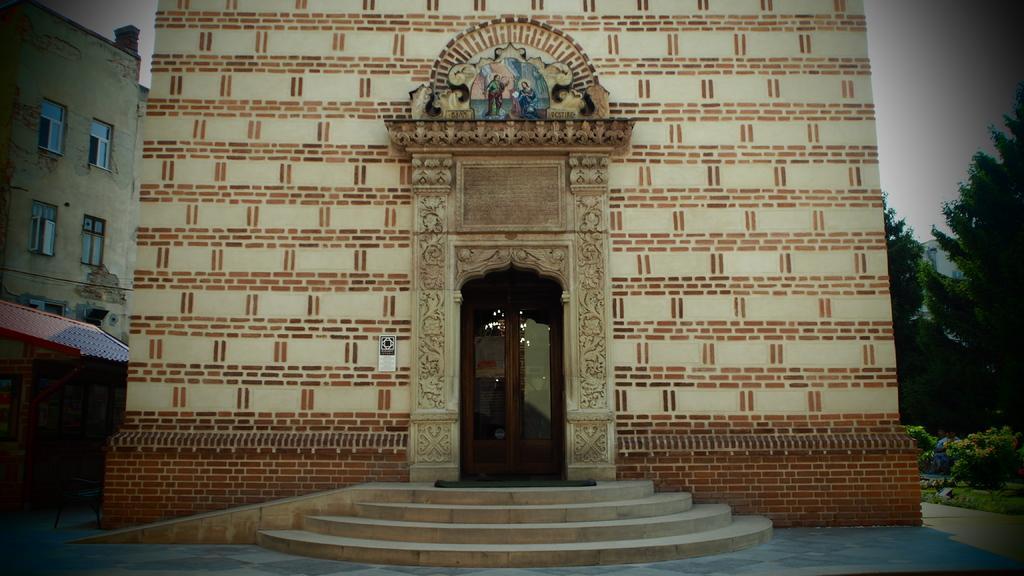Could you give a brief overview of what you see in this image? In this picture we can see buildings with windows, sun shade, steps, doors, statue, trees, plants and in the background we can see the sky. 